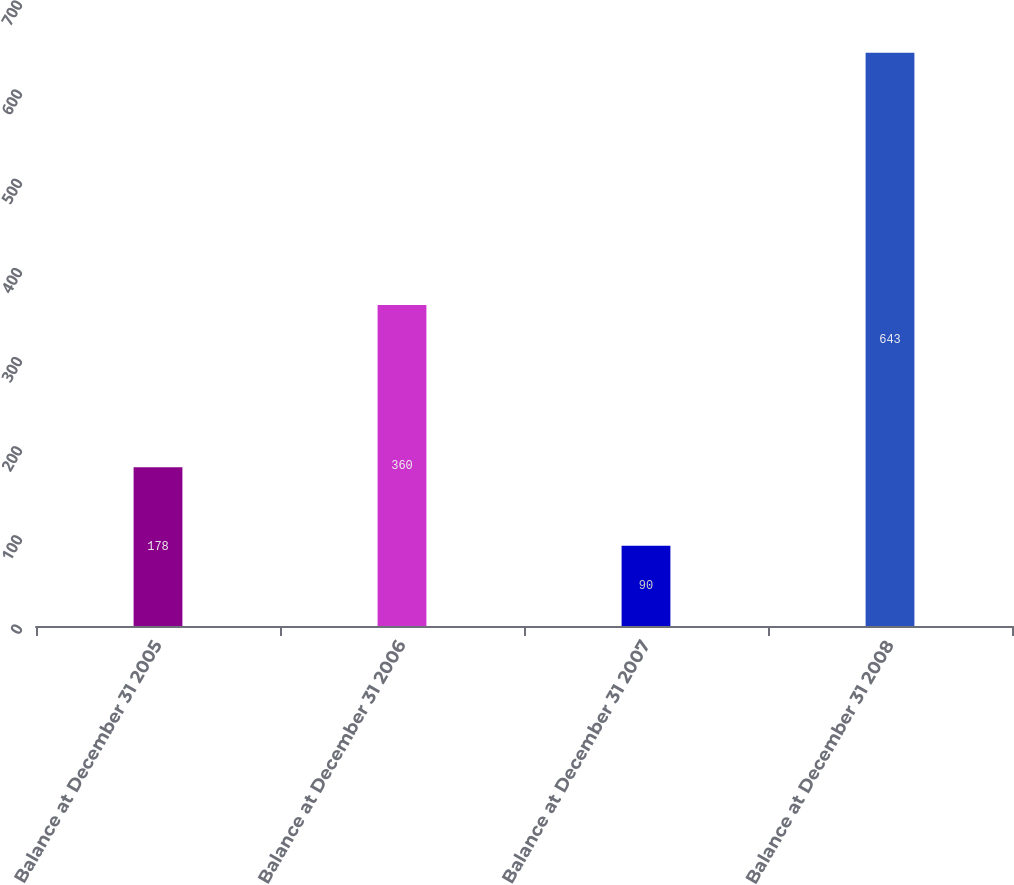Convert chart. <chart><loc_0><loc_0><loc_500><loc_500><bar_chart><fcel>Balance at December 31 2005<fcel>Balance at December 31 2006<fcel>Balance at December 31 2007<fcel>Balance at December 31 2008<nl><fcel>178<fcel>360<fcel>90<fcel>643<nl></chart> 